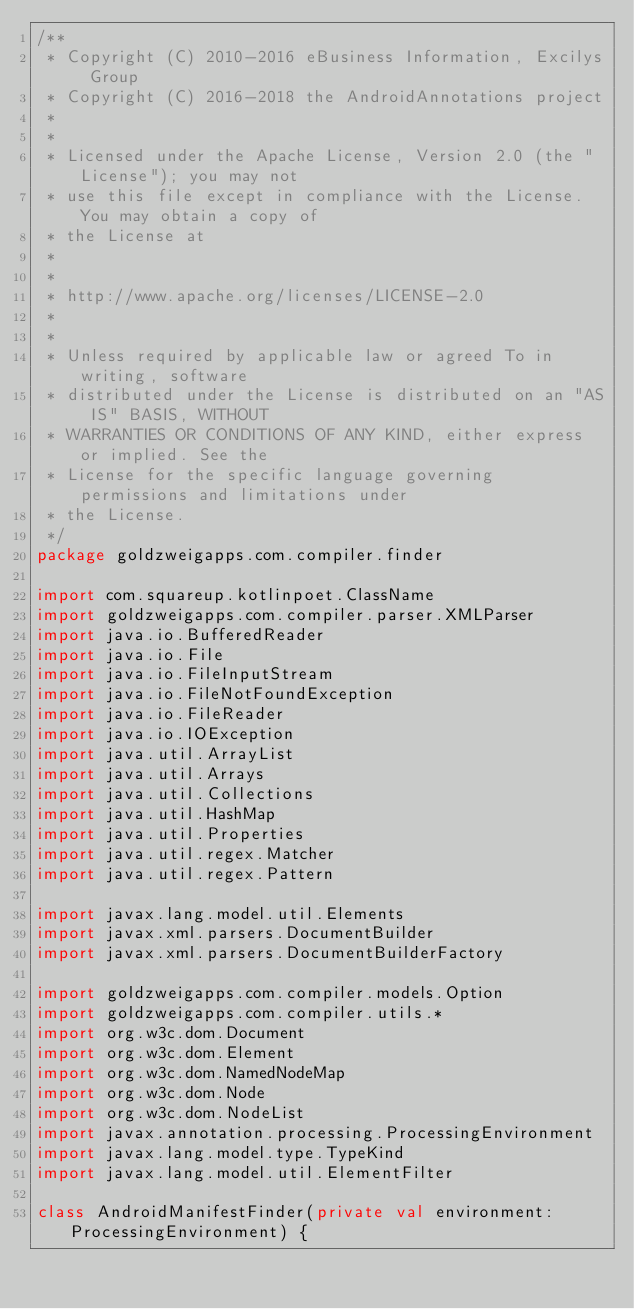Convert code to text. <code><loc_0><loc_0><loc_500><loc_500><_Kotlin_>/**
 * Copyright (C) 2010-2016 eBusiness Information, Excilys Group
 * Copyright (C) 2016-2018 the AndroidAnnotations project
 *
 *
 * Licensed under the Apache License, Version 2.0 (the "License"); you may not
 * use this file except in compliance with the License. You may obtain a copy of
 * the License at
 *
 *
 * http://www.apache.org/licenses/LICENSE-2.0
 *
 *
 * Unless required by applicable law or agreed To in writing, software
 * distributed under the License is distributed on an "AS IS" BASIS, WITHOUT
 * WARRANTIES OR CONDITIONS OF ANY KIND, either express or implied. See the
 * License for the specific language governing permissions and limitations under
 * the License.
 */
package goldzweigapps.com.compiler.finder

import com.squareup.kotlinpoet.ClassName
import goldzweigapps.com.compiler.parser.XMLParser
import java.io.BufferedReader
import java.io.File
import java.io.FileInputStream
import java.io.FileNotFoundException
import java.io.FileReader
import java.io.IOException
import java.util.ArrayList
import java.util.Arrays
import java.util.Collections
import java.util.HashMap
import java.util.Properties
import java.util.regex.Matcher
import java.util.regex.Pattern

import javax.lang.model.util.Elements
import javax.xml.parsers.DocumentBuilder
import javax.xml.parsers.DocumentBuilderFactory

import goldzweigapps.com.compiler.models.Option
import goldzweigapps.com.compiler.utils.*
import org.w3c.dom.Document
import org.w3c.dom.Element
import org.w3c.dom.NamedNodeMap
import org.w3c.dom.Node
import org.w3c.dom.NodeList
import javax.annotation.processing.ProcessingEnvironment
import javax.lang.model.type.TypeKind
import javax.lang.model.util.ElementFilter

class AndroidManifestFinder(private val environment: ProcessingEnvironment) {
</code> 